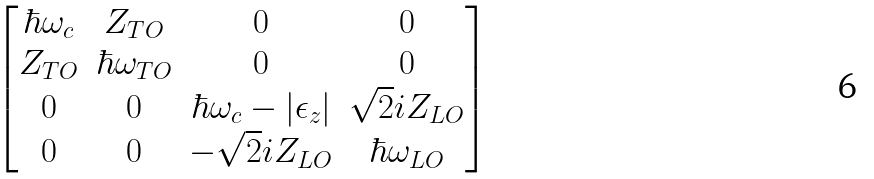Convert formula to latex. <formula><loc_0><loc_0><loc_500><loc_500>\begin{bmatrix} \hbar { \omega } _ { c } & Z _ { T O } & 0 & 0 \\ Z _ { T O } & \hbar { \omega } _ { T O } & 0 & 0 \\ 0 & 0 & \hbar { \omega } _ { c } - | \epsilon _ { z } | & \sqrt { 2 } i Z _ { L O } \\ 0 & 0 & - \sqrt { 2 } i Z _ { L O } & \hbar { \omega } _ { L O } \end{bmatrix}</formula> 